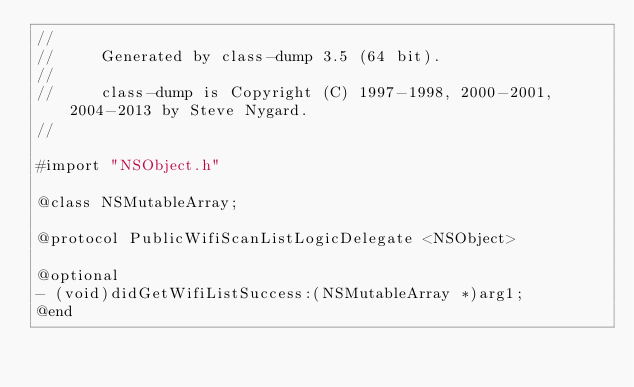<code> <loc_0><loc_0><loc_500><loc_500><_C_>//
//     Generated by class-dump 3.5 (64 bit).
//
//     class-dump is Copyright (C) 1997-1998, 2000-2001, 2004-2013 by Steve Nygard.
//

#import "NSObject.h"

@class NSMutableArray;

@protocol PublicWifiScanListLogicDelegate <NSObject>

@optional
- (void)didGetWifiListSuccess:(NSMutableArray *)arg1;
@end

</code> 